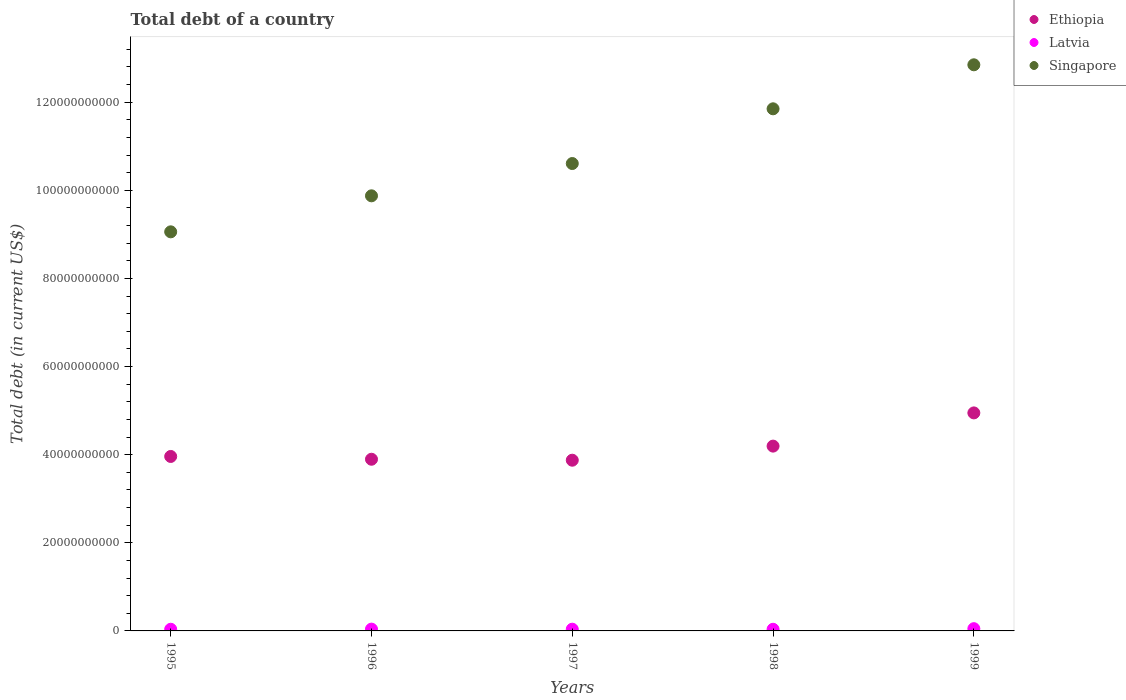How many different coloured dotlines are there?
Your answer should be compact. 3. What is the debt in Latvia in 1998?
Ensure brevity in your answer.  3.73e+08. Across all years, what is the maximum debt in Singapore?
Keep it short and to the point. 1.28e+11. Across all years, what is the minimum debt in Singapore?
Ensure brevity in your answer.  9.06e+1. In which year was the debt in Ethiopia minimum?
Offer a terse response. 1997. What is the total debt in Ethiopia in the graph?
Offer a terse response. 2.09e+11. What is the difference between the debt in Latvia in 1996 and that in 1998?
Provide a succinct answer. 3.55e+07. What is the difference between the debt in Singapore in 1995 and the debt in Latvia in 1999?
Offer a very short reply. 9.01e+1. What is the average debt in Latvia per year?
Your answer should be very brief. 4.12e+08. In the year 1997, what is the difference between the debt in Ethiopia and debt in Singapore?
Your answer should be compact. -6.73e+1. What is the ratio of the debt in Ethiopia in 1996 to that in 1998?
Give a very brief answer. 0.93. What is the difference between the highest and the second highest debt in Latvia?
Your answer should be compact. 1.03e+08. What is the difference between the highest and the lowest debt in Latvia?
Your response must be concise. 1.38e+08. In how many years, is the debt in Latvia greater than the average debt in Latvia taken over all years?
Provide a succinct answer. 1. Is it the case that in every year, the sum of the debt in Singapore and debt in Latvia  is greater than the debt in Ethiopia?
Your answer should be very brief. Yes. Is the debt in Singapore strictly less than the debt in Latvia over the years?
Your response must be concise. No. Are the values on the major ticks of Y-axis written in scientific E-notation?
Offer a terse response. No. Does the graph contain any zero values?
Make the answer very short. No. Does the graph contain grids?
Offer a very short reply. No. Where does the legend appear in the graph?
Make the answer very short. Top right. How are the legend labels stacked?
Your answer should be compact. Vertical. What is the title of the graph?
Provide a succinct answer. Total debt of a country. Does "Least developed countries" appear as one of the legend labels in the graph?
Give a very brief answer. No. What is the label or title of the Y-axis?
Offer a very short reply. Total debt (in current US$). What is the Total debt (in current US$) of Ethiopia in 1995?
Your response must be concise. 3.96e+1. What is the Total debt (in current US$) of Latvia in 1995?
Offer a very short reply. 3.76e+08. What is the Total debt (in current US$) in Singapore in 1995?
Give a very brief answer. 9.06e+1. What is the Total debt (in current US$) of Ethiopia in 1996?
Your answer should be compact. 3.90e+1. What is the Total debt (in current US$) in Latvia in 1996?
Offer a terse response. 4.08e+08. What is the Total debt (in current US$) of Singapore in 1996?
Keep it short and to the point. 9.88e+1. What is the Total debt (in current US$) of Ethiopia in 1997?
Your answer should be very brief. 3.87e+1. What is the Total debt (in current US$) of Latvia in 1997?
Make the answer very short. 3.92e+08. What is the Total debt (in current US$) of Singapore in 1997?
Keep it short and to the point. 1.06e+11. What is the Total debt (in current US$) of Ethiopia in 1998?
Offer a terse response. 4.19e+1. What is the Total debt (in current US$) of Latvia in 1998?
Provide a succinct answer. 3.73e+08. What is the Total debt (in current US$) in Singapore in 1998?
Offer a terse response. 1.19e+11. What is the Total debt (in current US$) of Ethiopia in 1999?
Ensure brevity in your answer.  4.95e+1. What is the Total debt (in current US$) in Latvia in 1999?
Provide a succinct answer. 5.11e+08. What is the Total debt (in current US$) in Singapore in 1999?
Keep it short and to the point. 1.28e+11. Across all years, what is the maximum Total debt (in current US$) in Ethiopia?
Your response must be concise. 4.95e+1. Across all years, what is the maximum Total debt (in current US$) of Latvia?
Provide a succinct answer. 5.11e+08. Across all years, what is the maximum Total debt (in current US$) in Singapore?
Keep it short and to the point. 1.28e+11. Across all years, what is the minimum Total debt (in current US$) in Ethiopia?
Keep it short and to the point. 3.87e+1. Across all years, what is the minimum Total debt (in current US$) in Latvia?
Make the answer very short. 3.73e+08. Across all years, what is the minimum Total debt (in current US$) of Singapore?
Make the answer very short. 9.06e+1. What is the total Total debt (in current US$) in Ethiopia in the graph?
Provide a succinct answer. 2.09e+11. What is the total Total debt (in current US$) of Latvia in the graph?
Give a very brief answer. 2.06e+09. What is the total Total debt (in current US$) of Singapore in the graph?
Your answer should be very brief. 5.42e+11. What is the difference between the Total debt (in current US$) of Ethiopia in 1995 and that in 1996?
Your answer should be compact. 6.33e+08. What is the difference between the Total debt (in current US$) in Latvia in 1995 and that in 1996?
Your answer should be very brief. -3.17e+07. What is the difference between the Total debt (in current US$) of Singapore in 1995 and that in 1996?
Offer a very short reply. -8.17e+09. What is the difference between the Total debt (in current US$) in Ethiopia in 1995 and that in 1997?
Ensure brevity in your answer.  8.51e+08. What is the difference between the Total debt (in current US$) in Latvia in 1995 and that in 1997?
Offer a very short reply. -1.54e+07. What is the difference between the Total debt (in current US$) in Singapore in 1995 and that in 1997?
Provide a short and direct response. -1.55e+1. What is the difference between the Total debt (in current US$) in Ethiopia in 1995 and that in 1998?
Your answer should be very brief. -2.35e+09. What is the difference between the Total debt (in current US$) in Latvia in 1995 and that in 1998?
Keep it short and to the point. 3.82e+06. What is the difference between the Total debt (in current US$) of Singapore in 1995 and that in 1998?
Offer a terse response. -2.79e+1. What is the difference between the Total debt (in current US$) in Ethiopia in 1995 and that in 1999?
Your answer should be compact. -9.89e+09. What is the difference between the Total debt (in current US$) of Latvia in 1995 and that in 1999?
Make the answer very short. -1.34e+08. What is the difference between the Total debt (in current US$) of Singapore in 1995 and that in 1999?
Your answer should be compact. -3.79e+1. What is the difference between the Total debt (in current US$) in Ethiopia in 1996 and that in 1997?
Provide a short and direct response. 2.19e+08. What is the difference between the Total debt (in current US$) in Latvia in 1996 and that in 1997?
Your answer should be very brief. 1.63e+07. What is the difference between the Total debt (in current US$) of Singapore in 1996 and that in 1997?
Offer a terse response. -7.33e+09. What is the difference between the Total debt (in current US$) of Ethiopia in 1996 and that in 1998?
Keep it short and to the point. -2.98e+09. What is the difference between the Total debt (in current US$) of Latvia in 1996 and that in 1998?
Your response must be concise. 3.55e+07. What is the difference between the Total debt (in current US$) of Singapore in 1996 and that in 1998?
Your response must be concise. -1.98e+1. What is the difference between the Total debt (in current US$) of Ethiopia in 1996 and that in 1999?
Offer a terse response. -1.05e+1. What is the difference between the Total debt (in current US$) in Latvia in 1996 and that in 1999?
Give a very brief answer. -1.03e+08. What is the difference between the Total debt (in current US$) of Singapore in 1996 and that in 1999?
Make the answer very short. -2.97e+1. What is the difference between the Total debt (in current US$) in Ethiopia in 1997 and that in 1998?
Keep it short and to the point. -3.20e+09. What is the difference between the Total debt (in current US$) in Latvia in 1997 and that in 1998?
Make the answer very short. 1.92e+07. What is the difference between the Total debt (in current US$) in Singapore in 1997 and that in 1998?
Offer a terse response. -1.24e+1. What is the difference between the Total debt (in current US$) in Ethiopia in 1997 and that in 1999?
Give a very brief answer. -1.07e+1. What is the difference between the Total debt (in current US$) in Latvia in 1997 and that in 1999?
Offer a terse response. -1.19e+08. What is the difference between the Total debt (in current US$) of Singapore in 1997 and that in 1999?
Make the answer very short. -2.24e+1. What is the difference between the Total debt (in current US$) of Ethiopia in 1998 and that in 1999?
Give a very brief answer. -7.54e+09. What is the difference between the Total debt (in current US$) of Latvia in 1998 and that in 1999?
Keep it short and to the point. -1.38e+08. What is the difference between the Total debt (in current US$) in Singapore in 1998 and that in 1999?
Ensure brevity in your answer.  -9.99e+09. What is the difference between the Total debt (in current US$) in Ethiopia in 1995 and the Total debt (in current US$) in Latvia in 1996?
Your answer should be compact. 3.92e+1. What is the difference between the Total debt (in current US$) of Ethiopia in 1995 and the Total debt (in current US$) of Singapore in 1996?
Keep it short and to the point. -5.92e+1. What is the difference between the Total debt (in current US$) of Latvia in 1995 and the Total debt (in current US$) of Singapore in 1996?
Ensure brevity in your answer.  -9.84e+1. What is the difference between the Total debt (in current US$) in Ethiopia in 1995 and the Total debt (in current US$) in Latvia in 1997?
Make the answer very short. 3.92e+1. What is the difference between the Total debt (in current US$) of Ethiopia in 1995 and the Total debt (in current US$) of Singapore in 1997?
Your answer should be compact. -6.65e+1. What is the difference between the Total debt (in current US$) of Latvia in 1995 and the Total debt (in current US$) of Singapore in 1997?
Your answer should be compact. -1.06e+11. What is the difference between the Total debt (in current US$) in Ethiopia in 1995 and the Total debt (in current US$) in Latvia in 1998?
Your response must be concise. 3.92e+1. What is the difference between the Total debt (in current US$) of Ethiopia in 1995 and the Total debt (in current US$) of Singapore in 1998?
Keep it short and to the point. -7.89e+1. What is the difference between the Total debt (in current US$) in Latvia in 1995 and the Total debt (in current US$) in Singapore in 1998?
Offer a very short reply. -1.18e+11. What is the difference between the Total debt (in current US$) in Ethiopia in 1995 and the Total debt (in current US$) in Latvia in 1999?
Your answer should be compact. 3.91e+1. What is the difference between the Total debt (in current US$) of Ethiopia in 1995 and the Total debt (in current US$) of Singapore in 1999?
Your answer should be compact. -8.89e+1. What is the difference between the Total debt (in current US$) of Latvia in 1995 and the Total debt (in current US$) of Singapore in 1999?
Your answer should be compact. -1.28e+11. What is the difference between the Total debt (in current US$) in Ethiopia in 1996 and the Total debt (in current US$) in Latvia in 1997?
Your answer should be compact. 3.86e+1. What is the difference between the Total debt (in current US$) in Ethiopia in 1996 and the Total debt (in current US$) in Singapore in 1997?
Give a very brief answer. -6.71e+1. What is the difference between the Total debt (in current US$) in Latvia in 1996 and the Total debt (in current US$) in Singapore in 1997?
Make the answer very short. -1.06e+11. What is the difference between the Total debt (in current US$) in Ethiopia in 1996 and the Total debt (in current US$) in Latvia in 1998?
Offer a very short reply. 3.86e+1. What is the difference between the Total debt (in current US$) in Ethiopia in 1996 and the Total debt (in current US$) in Singapore in 1998?
Give a very brief answer. -7.95e+1. What is the difference between the Total debt (in current US$) in Latvia in 1996 and the Total debt (in current US$) in Singapore in 1998?
Offer a very short reply. -1.18e+11. What is the difference between the Total debt (in current US$) in Ethiopia in 1996 and the Total debt (in current US$) in Latvia in 1999?
Your response must be concise. 3.85e+1. What is the difference between the Total debt (in current US$) in Ethiopia in 1996 and the Total debt (in current US$) in Singapore in 1999?
Ensure brevity in your answer.  -8.95e+1. What is the difference between the Total debt (in current US$) in Latvia in 1996 and the Total debt (in current US$) in Singapore in 1999?
Keep it short and to the point. -1.28e+11. What is the difference between the Total debt (in current US$) in Ethiopia in 1997 and the Total debt (in current US$) in Latvia in 1998?
Provide a short and direct response. 3.84e+1. What is the difference between the Total debt (in current US$) of Ethiopia in 1997 and the Total debt (in current US$) of Singapore in 1998?
Provide a succinct answer. -7.98e+1. What is the difference between the Total debt (in current US$) of Latvia in 1997 and the Total debt (in current US$) of Singapore in 1998?
Keep it short and to the point. -1.18e+11. What is the difference between the Total debt (in current US$) in Ethiopia in 1997 and the Total debt (in current US$) in Latvia in 1999?
Give a very brief answer. 3.82e+1. What is the difference between the Total debt (in current US$) in Ethiopia in 1997 and the Total debt (in current US$) in Singapore in 1999?
Your answer should be compact. -8.97e+1. What is the difference between the Total debt (in current US$) in Latvia in 1997 and the Total debt (in current US$) in Singapore in 1999?
Your answer should be very brief. -1.28e+11. What is the difference between the Total debt (in current US$) of Ethiopia in 1998 and the Total debt (in current US$) of Latvia in 1999?
Ensure brevity in your answer.  4.14e+1. What is the difference between the Total debt (in current US$) of Ethiopia in 1998 and the Total debt (in current US$) of Singapore in 1999?
Your response must be concise. -8.66e+1. What is the difference between the Total debt (in current US$) in Latvia in 1998 and the Total debt (in current US$) in Singapore in 1999?
Your answer should be very brief. -1.28e+11. What is the average Total debt (in current US$) in Ethiopia per year?
Offer a terse response. 4.17e+1. What is the average Total debt (in current US$) of Latvia per year?
Your response must be concise. 4.12e+08. What is the average Total debt (in current US$) of Singapore per year?
Provide a short and direct response. 1.08e+11. In the year 1995, what is the difference between the Total debt (in current US$) of Ethiopia and Total debt (in current US$) of Latvia?
Keep it short and to the point. 3.92e+1. In the year 1995, what is the difference between the Total debt (in current US$) of Ethiopia and Total debt (in current US$) of Singapore?
Give a very brief answer. -5.10e+1. In the year 1995, what is the difference between the Total debt (in current US$) of Latvia and Total debt (in current US$) of Singapore?
Your response must be concise. -9.02e+1. In the year 1996, what is the difference between the Total debt (in current US$) in Ethiopia and Total debt (in current US$) in Latvia?
Provide a succinct answer. 3.86e+1. In the year 1996, what is the difference between the Total debt (in current US$) in Ethiopia and Total debt (in current US$) in Singapore?
Give a very brief answer. -5.98e+1. In the year 1996, what is the difference between the Total debt (in current US$) in Latvia and Total debt (in current US$) in Singapore?
Offer a very short reply. -9.83e+1. In the year 1997, what is the difference between the Total debt (in current US$) in Ethiopia and Total debt (in current US$) in Latvia?
Your answer should be compact. 3.84e+1. In the year 1997, what is the difference between the Total debt (in current US$) in Ethiopia and Total debt (in current US$) in Singapore?
Your answer should be compact. -6.73e+1. In the year 1997, what is the difference between the Total debt (in current US$) in Latvia and Total debt (in current US$) in Singapore?
Ensure brevity in your answer.  -1.06e+11. In the year 1998, what is the difference between the Total debt (in current US$) of Ethiopia and Total debt (in current US$) of Latvia?
Your response must be concise. 4.16e+1. In the year 1998, what is the difference between the Total debt (in current US$) of Ethiopia and Total debt (in current US$) of Singapore?
Give a very brief answer. -7.66e+1. In the year 1998, what is the difference between the Total debt (in current US$) of Latvia and Total debt (in current US$) of Singapore?
Ensure brevity in your answer.  -1.18e+11. In the year 1999, what is the difference between the Total debt (in current US$) in Ethiopia and Total debt (in current US$) in Latvia?
Provide a short and direct response. 4.90e+1. In the year 1999, what is the difference between the Total debt (in current US$) in Ethiopia and Total debt (in current US$) in Singapore?
Provide a short and direct response. -7.90e+1. In the year 1999, what is the difference between the Total debt (in current US$) of Latvia and Total debt (in current US$) of Singapore?
Make the answer very short. -1.28e+11. What is the ratio of the Total debt (in current US$) in Ethiopia in 1995 to that in 1996?
Give a very brief answer. 1.02. What is the ratio of the Total debt (in current US$) in Latvia in 1995 to that in 1996?
Give a very brief answer. 0.92. What is the ratio of the Total debt (in current US$) in Singapore in 1995 to that in 1996?
Ensure brevity in your answer.  0.92. What is the ratio of the Total debt (in current US$) in Ethiopia in 1995 to that in 1997?
Provide a succinct answer. 1.02. What is the ratio of the Total debt (in current US$) in Latvia in 1995 to that in 1997?
Ensure brevity in your answer.  0.96. What is the ratio of the Total debt (in current US$) in Singapore in 1995 to that in 1997?
Ensure brevity in your answer.  0.85. What is the ratio of the Total debt (in current US$) of Ethiopia in 1995 to that in 1998?
Make the answer very short. 0.94. What is the ratio of the Total debt (in current US$) of Latvia in 1995 to that in 1998?
Your answer should be very brief. 1.01. What is the ratio of the Total debt (in current US$) in Singapore in 1995 to that in 1998?
Make the answer very short. 0.76. What is the ratio of the Total debt (in current US$) of Ethiopia in 1995 to that in 1999?
Give a very brief answer. 0.8. What is the ratio of the Total debt (in current US$) of Latvia in 1995 to that in 1999?
Provide a short and direct response. 0.74. What is the ratio of the Total debt (in current US$) in Singapore in 1995 to that in 1999?
Offer a very short reply. 0.7. What is the ratio of the Total debt (in current US$) in Ethiopia in 1996 to that in 1997?
Keep it short and to the point. 1.01. What is the ratio of the Total debt (in current US$) in Latvia in 1996 to that in 1997?
Offer a very short reply. 1.04. What is the ratio of the Total debt (in current US$) of Singapore in 1996 to that in 1997?
Offer a terse response. 0.93. What is the ratio of the Total debt (in current US$) of Ethiopia in 1996 to that in 1998?
Offer a terse response. 0.93. What is the ratio of the Total debt (in current US$) of Latvia in 1996 to that in 1998?
Provide a short and direct response. 1.1. What is the ratio of the Total debt (in current US$) in Singapore in 1996 to that in 1998?
Ensure brevity in your answer.  0.83. What is the ratio of the Total debt (in current US$) in Ethiopia in 1996 to that in 1999?
Your response must be concise. 0.79. What is the ratio of the Total debt (in current US$) of Latvia in 1996 to that in 1999?
Your answer should be compact. 0.8. What is the ratio of the Total debt (in current US$) of Singapore in 1996 to that in 1999?
Keep it short and to the point. 0.77. What is the ratio of the Total debt (in current US$) in Ethiopia in 1997 to that in 1998?
Provide a succinct answer. 0.92. What is the ratio of the Total debt (in current US$) in Latvia in 1997 to that in 1998?
Ensure brevity in your answer.  1.05. What is the ratio of the Total debt (in current US$) in Singapore in 1997 to that in 1998?
Offer a very short reply. 0.9. What is the ratio of the Total debt (in current US$) of Ethiopia in 1997 to that in 1999?
Keep it short and to the point. 0.78. What is the ratio of the Total debt (in current US$) of Latvia in 1997 to that in 1999?
Provide a succinct answer. 0.77. What is the ratio of the Total debt (in current US$) of Singapore in 1997 to that in 1999?
Your response must be concise. 0.83. What is the ratio of the Total debt (in current US$) in Ethiopia in 1998 to that in 1999?
Offer a terse response. 0.85. What is the ratio of the Total debt (in current US$) in Latvia in 1998 to that in 1999?
Keep it short and to the point. 0.73. What is the ratio of the Total debt (in current US$) of Singapore in 1998 to that in 1999?
Give a very brief answer. 0.92. What is the difference between the highest and the second highest Total debt (in current US$) of Ethiopia?
Provide a short and direct response. 7.54e+09. What is the difference between the highest and the second highest Total debt (in current US$) in Latvia?
Offer a terse response. 1.03e+08. What is the difference between the highest and the second highest Total debt (in current US$) in Singapore?
Keep it short and to the point. 9.99e+09. What is the difference between the highest and the lowest Total debt (in current US$) in Ethiopia?
Offer a terse response. 1.07e+1. What is the difference between the highest and the lowest Total debt (in current US$) of Latvia?
Keep it short and to the point. 1.38e+08. What is the difference between the highest and the lowest Total debt (in current US$) in Singapore?
Provide a short and direct response. 3.79e+1. 